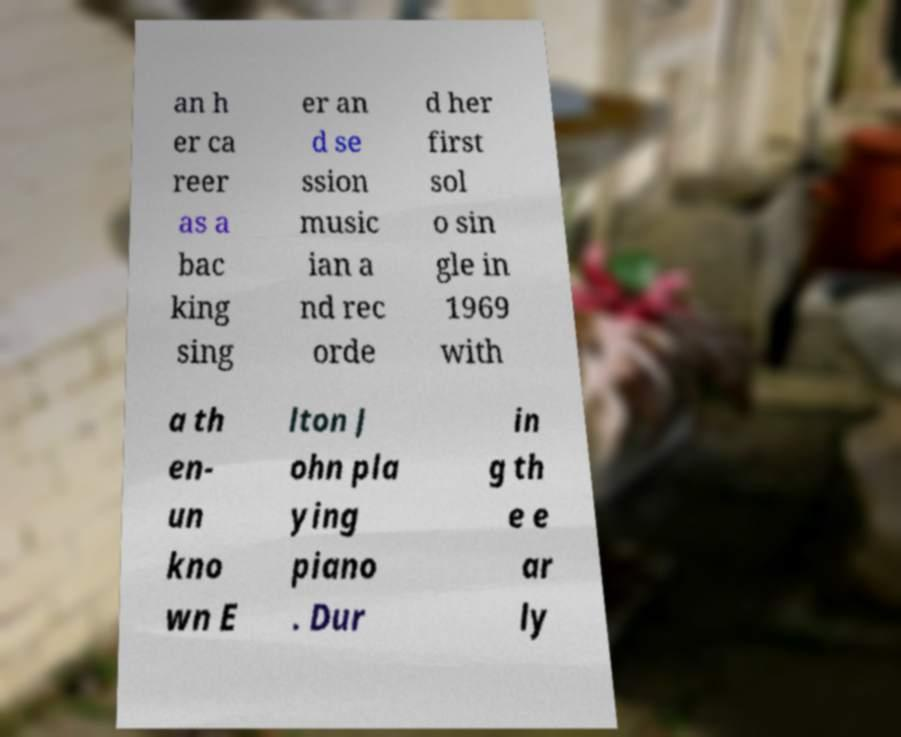There's text embedded in this image that I need extracted. Can you transcribe it verbatim? an h er ca reer as a bac king sing er an d se ssion music ian a nd rec orde d her first sol o sin gle in 1969 with a th en- un kno wn E lton J ohn pla ying piano . Dur in g th e e ar ly 